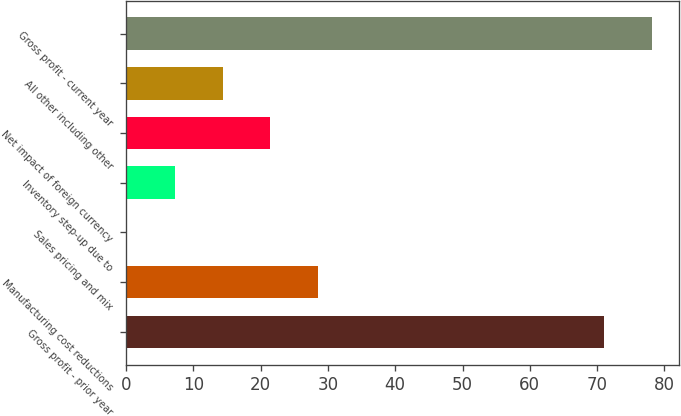<chart> <loc_0><loc_0><loc_500><loc_500><bar_chart><fcel>Gross profit - prior year<fcel>Manufacturing cost reductions<fcel>Sales pricing and mix<fcel>Inventory step-up due to<fcel>Net impact of foreign currency<fcel>All other including other<fcel>Gross profit - current year<nl><fcel>71.1<fcel>28.58<fcel>0.1<fcel>7.22<fcel>21.46<fcel>14.34<fcel>78.22<nl></chart> 